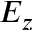Convert formula to latex. <formula><loc_0><loc_0><loc_500><loc_500>E _ { z }</formula> 